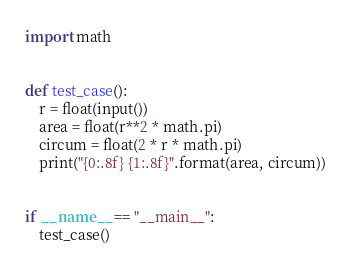Convert code to text. <code><loc_0><loc_0><loc_500><loc_500><_Python_>import math


def test_case():
    r = float(input())
    area = float(r**2 * math.pi)
    circum = float(2 * r * math.pi)
    print("{0:.8f} {1:.8f}".format(area, circum))


if __name__ == "__main__":
    test_case()

</code> 